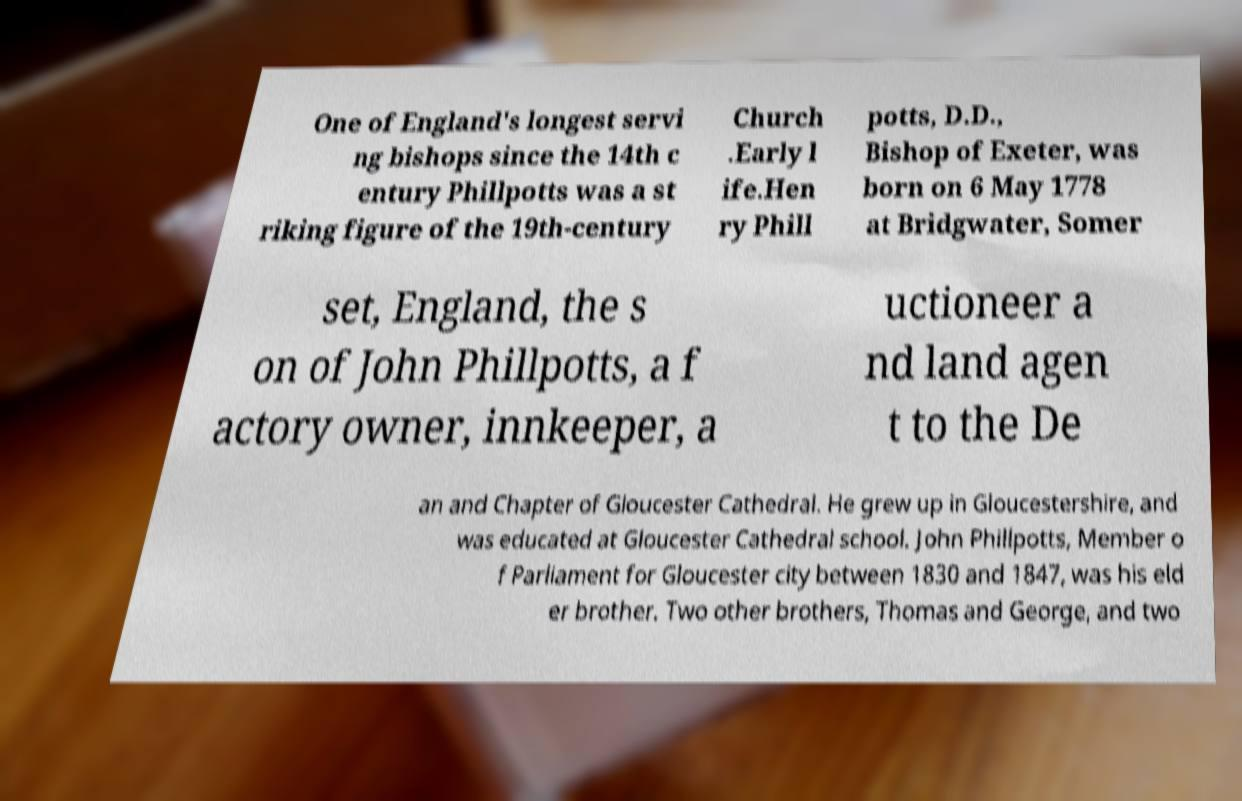Could you extract and type out the text from this image? One of England's longest servi ng bishops since the 14th c entury Phillpotts was a st riking figure of the 19th-century Church .Early l ife.Hen ry Phill potts, D.D., Bishop of Exeter, was born on 6 May 1778 at Bridgwater, Somer set, England, the s on of John Phillpotts, a f actory owner, innkeeper, a uctioneer a nd land agen t to the De an and Chapter of Gloucester Cathedral. He grew up in Gloucestershire, and was educated at Gloucester Cathedral school. John Phillpotts, Member o f Parliament for Gloucester city between 1830 and 1847, was his eld er brother. Two other brothers, Thomas and George, and two 